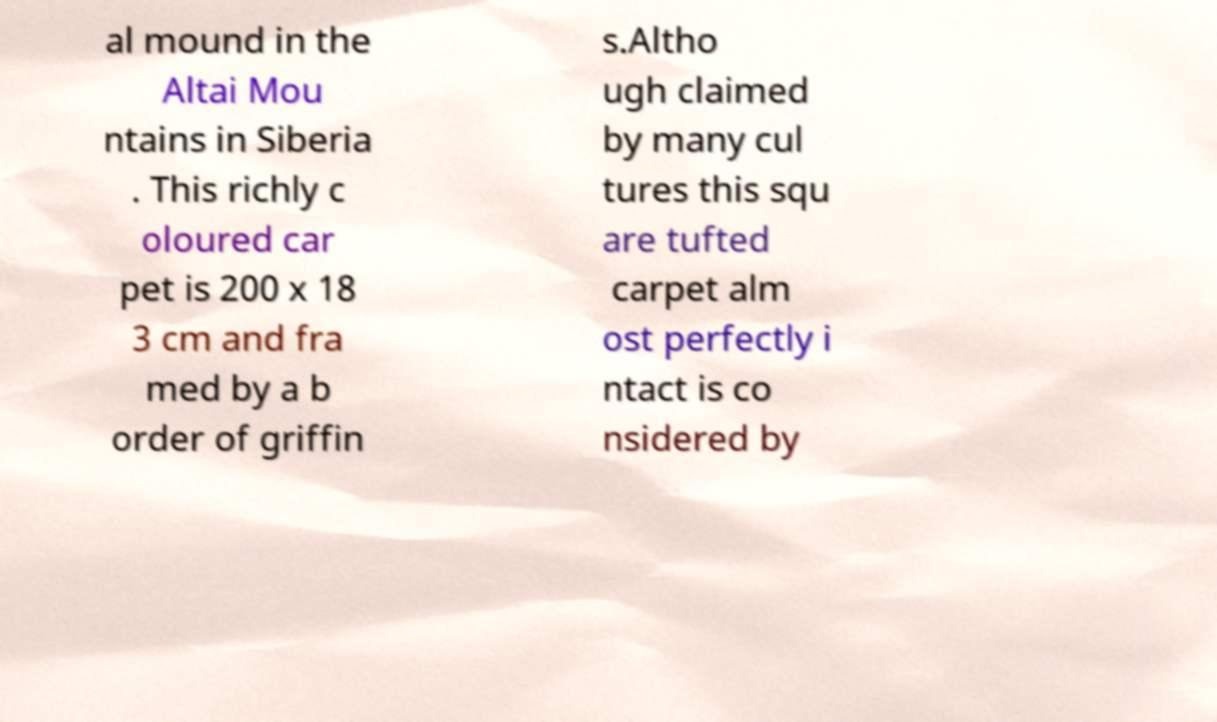Please read and relay the text visible in this image. What does it say? al mound in the Altai Mou ntains in Siberia . This richly c oloured car pet is 200 x 18 3 cm and fra med by a b order of griffin s.Altho ugh claimed by many cul tures this squ are tufted carpet alm ost perfectly i ntact is co nsidered by 